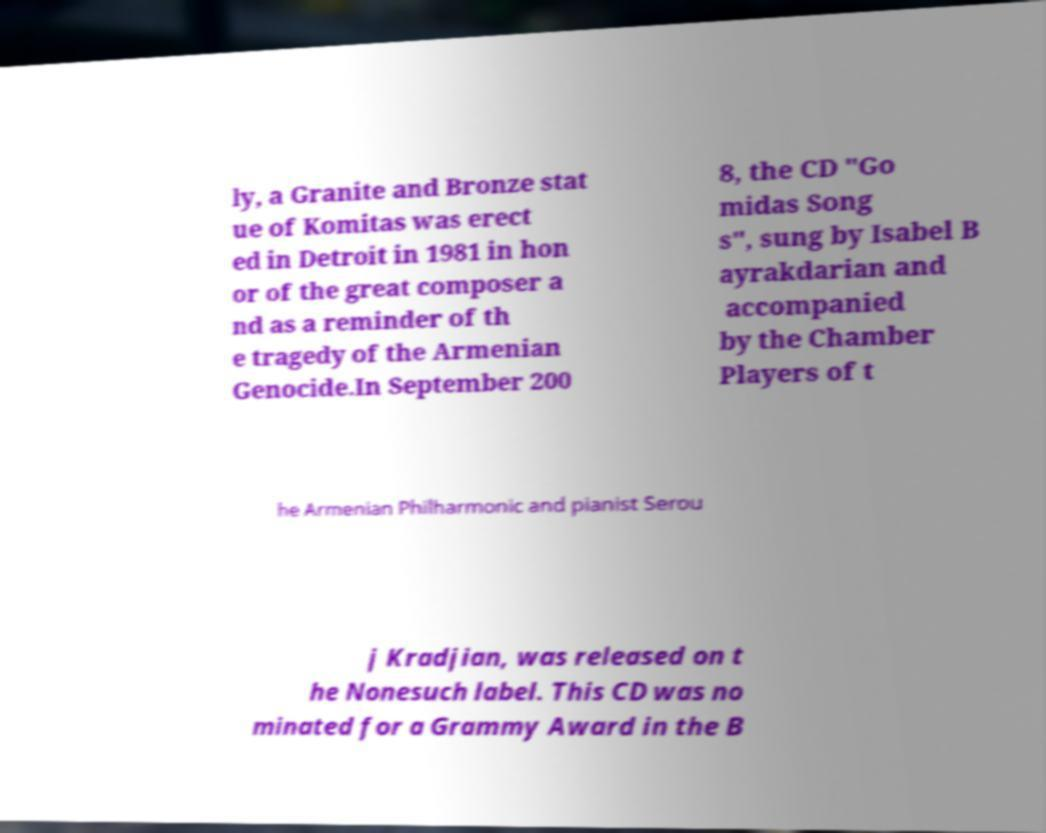Please read and relay the text visible in this image. What does it say? ly, a Granite and Bronze stat ue of Komitas was erect ed in Detroit in 1981 in hon or of the great composer a nd as a reminder of th e tragedy of the Armenian Genocide.In September 200 8, the CD "Go midas Song s", sung by Isabel B ayrakdarian and accompanied by the Chamber Players of t he Armenian Philharmonic and pianist Serou j Kradjian, was released on t he Nonesuch label. This CD was no minated for a Grammy Award in the B 